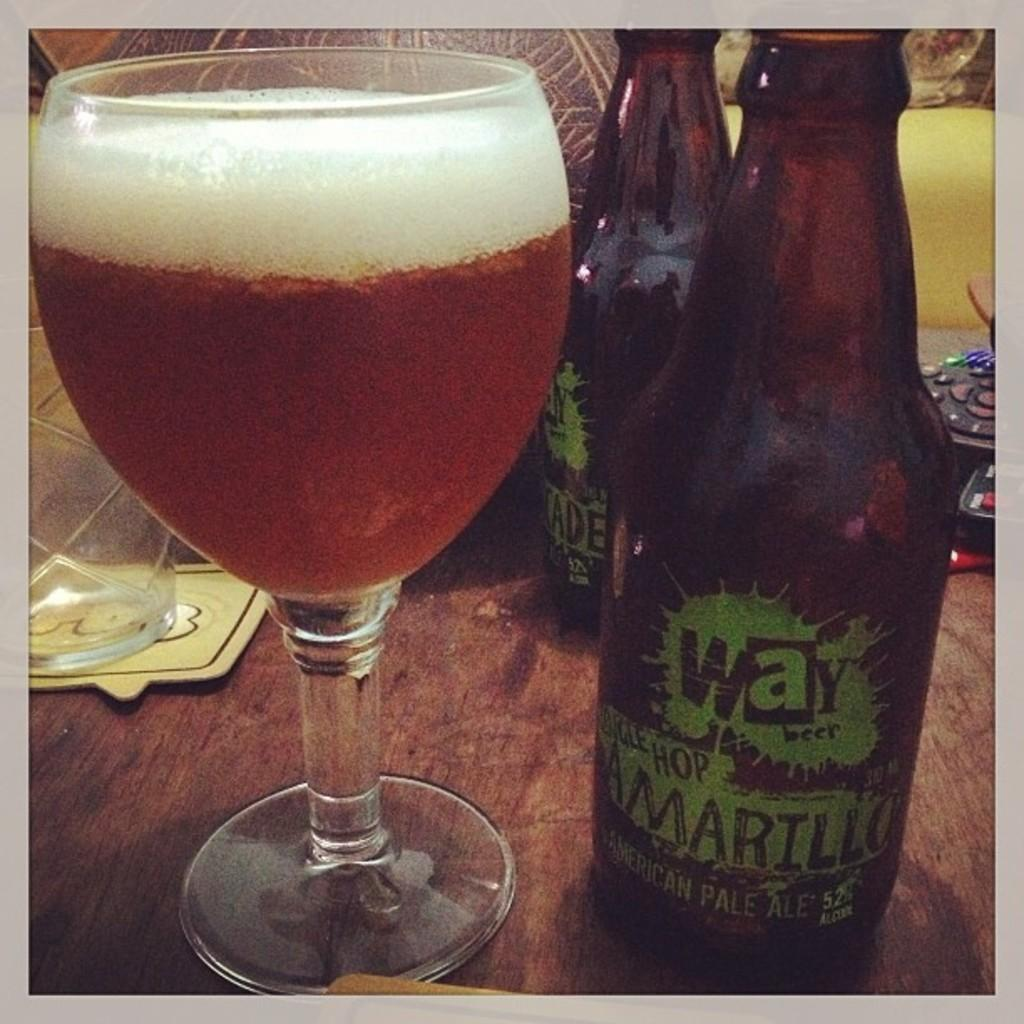<image>
Offer a succinct explanation of the picture presented. A bottle of beer from Way Beer titled Amarillo sits on a table next to a glass of poured beer. 